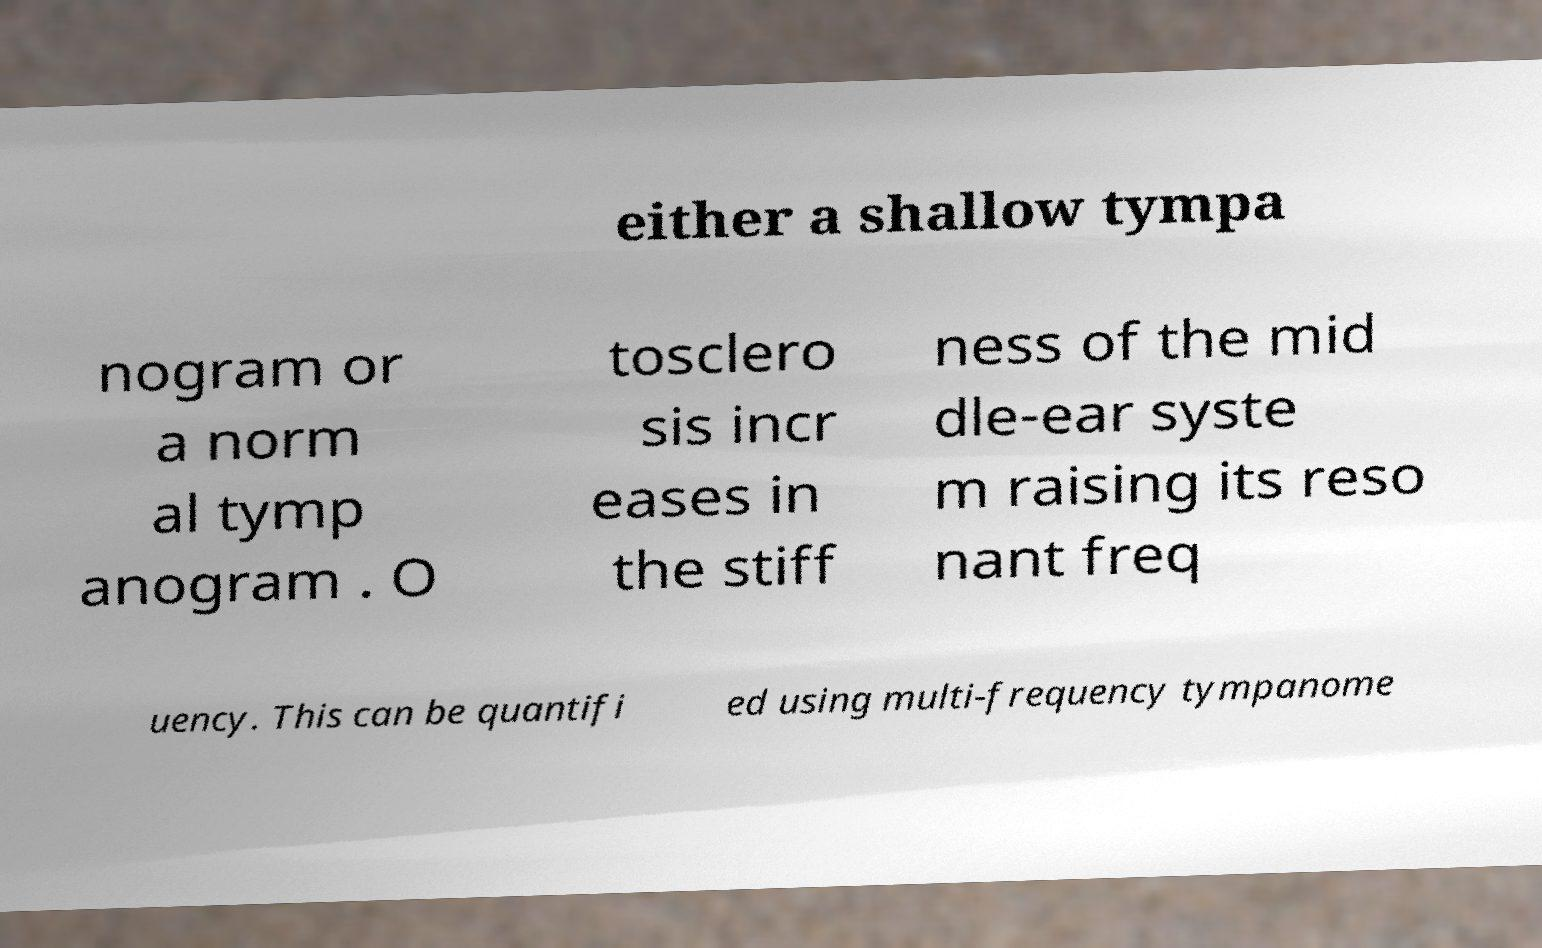There's text embedded in this image that I need extracted. Can you transcribe it verbatim? either a shallow tympa nogram or a norm al tymp anogram . O tosclero sis incr eases in the stiff ness of the mid dle-ear syste m raising its reso nant freq uency. This can be quantifi ed using multi-frequency tympanome 